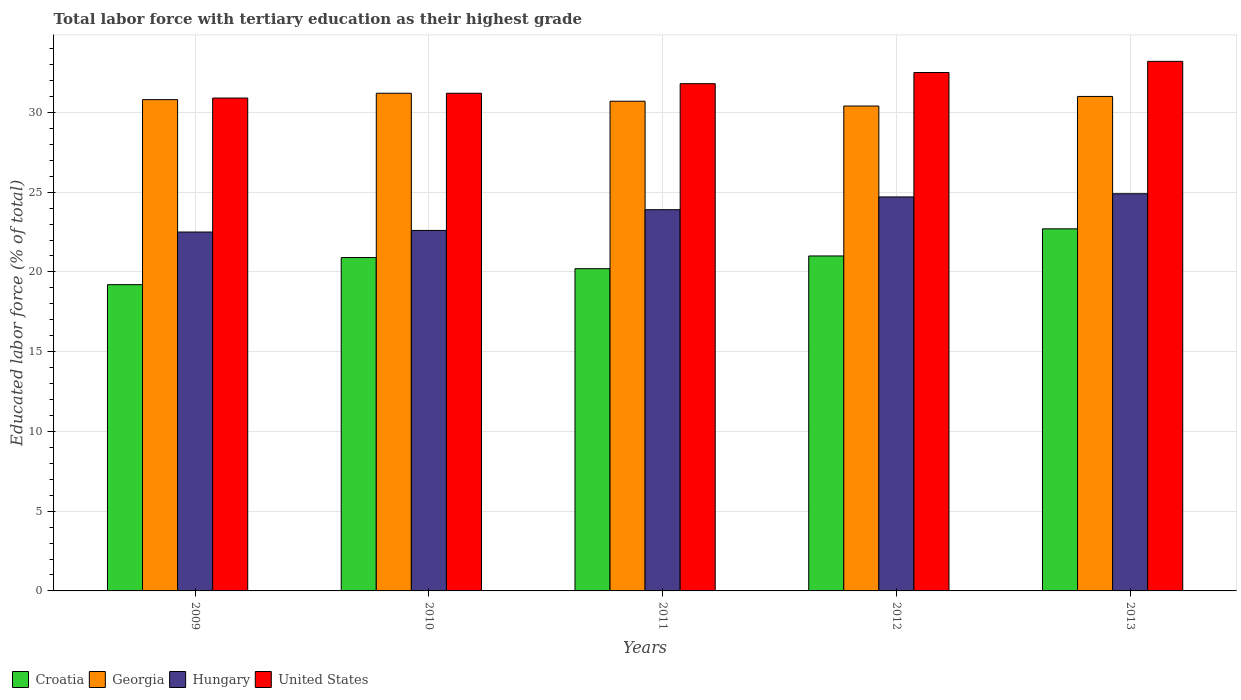How many groups of bars are there?
Give a very brief answer. 5. Are the number of bars on each tick of the X-axis equal?
Make the answer very short. Yes. What is the label of the 4th group of bars from the left?
Ensure brevity in your answer.  2012. In how many cases, is the number of bars for a given year not equal to the number of legend labels?
Your answer should be compact. 0. What is the percentage of male labor force with tertiary education in Georgia in 2010?
Offer a very short reply. 31.2. Across all years, what is the maximum percentage of male labor force with tertiary education in Croatia?
Offer a very short reply. 22.7. Across all years, what is the minimum percentage of male labor force with tertiary education in Georgia?
Provide a succinct answer. 30.4. In which year was the percentage of male labor force with tertiary education in Croatia maximum?
Ensure brevity in your answer.  2013. What is the total percentage of male labor force with tertiary education in Georgia in the graph?
Make the answer very short. 154.1. What is the difference between the percentage of male labor force with tertiary education in Croatia in 2009 and that in 2013?
Offer a terse response. -3.5. What is the difference between the percentage of male labor force with tertiary education in United States in 2009 and the percentage of male labor force with tertiary education in Hungary in 2012?
Keep it short and to the point. 6.2. What is the average percentage of male labor force with tertiary education in Hungary per year?
Offer a very short reply. 23.72. In the year 2009, what is the difference between the percentage of male labor force with tertiary education in Croatia and percentage of male labor force with tertiary education in United States?
Your response must be concise. -11.7. What is the ratio of the percentage of male labor force with tertiary education in Georgia in 2010 to that in 2011?
Your answer should be compact. 1.02. Is the difference between the percentage of male labor force with tertiary education in Croatia in 2009 and 2013 greater than the difference between the percentage of male labor force with tertiary education in United States in 2009 and 2013?
Your response must be concise. No. What is the difference between the highest and the second highest percentage of male labor force with tertiary education in Georgia?
Your answer should be very brief. 0.2. What is the difference between the highest and the lowest percentage of male labor force with tertiary education in Hungary?
Provide a short and direct response. 2.4. In how many years, is the percentage of male labor force with tertiary education in Georgia greater than the average percentage of male labor force with tertiary education in Georgia taken over all years?
Your answer should be very brief. 2. What does the 2nd bar from the left in 2011 represents?
Keep it short and to the point. Georgia. Is it the case that in every year, the sum of the percentage of male labor force with tertiary education in Croatia and percentage of male labor force with tertiary education in Georgia is greater than the percentage of male labor force with tertiary education in Hungary?
Your answer should be very brief. Yes. Are all the bars in the graph horizontal?
Your response must be concise. No. What is the difference between two consecutive major ticks on the Y-axis?
Offer a terse response. 5. Are the values on the major ticks of Y-axis written in scientific E-notation?
Offer a terse response. No. Does the graph contain any zero values?
Offer a very short reply. No. Does the graph contain grids?
Keep it short and to the point. Yes. Where does the legend appear in the graph?
Provide a short and direct response. Bottom left. How are the legend labels stacked?
Give a very brief answer. Horizontal. What is the title of the graph?
Make the answer very short. Total labor force with tertiary education as their highest grade. Does "Malaysia" appear as one of the legend labels in the graph?
Ensure brevity in your answer.  No. What is the label or title of the X-axis?
Your answer should be very brief. Years. What is the label or title of the Y-axis?
Keep it short and to the point. Educated labor force (% of total). What is the Educated labor force (% of total) of Croatia in 2009?
Give a very brief answer. 19.2. What is the Educated labor force (% of total) of Georgia in 2009?
Provide a succinct answer. 30.8. What is the Educated labor force (% of total) in United States in 2009?
Offer a terse response. 30.9. What is the Educated labor force (% of total) of Croatia in 2010?
Give a very brief answer. 20.9. What is the Educated labor force (% of total) of Georgia in 2010?
Make the answer very short. 31.2. What is the Educated labor force (% of total) in Hungary in 2010?
Make the answer very short. 22.6. What is the Educated labor force (% of total) of United States in 2010?
Ensure brevity in your answer.  31.2. What is the Educated labor force (% of total) in Croatia in 2011?
Make the answer very short. 20.2. What is the Educated labor force (% of total) of Georgia in 2011?
Your answer should be very brief. 30.7. What is the Educated labor force (% of total) of Hungary in 2011?
Offer a terse response. 23.9. What is the Educated labor force (% of total) of United States in 2011?
Make the answer very short. 31.8. What is the Educated labor force (% of total) of Georgia in 2012?
Offer a terse response. 30.4. What is the Educated labor force (% of total) of Hungary in 2012?
Offer a very short reply. 24.7. What is the Educated labor force (% of total) in United States in 2012?
Offer a very short reply. 32.5. What is the Educated labor force (% of total) of Croatia in 2013?
Provide a succinct answer. 22.7. What is the Educated labor force (% of total) in Hungary in 2013?
Provide a short and direct response. 24.9. What is the Educated labor force (% of total) in United States in 2013?
Your answer should be very brief. 33.2. Across all years, what is the maximum Educated labor force (% of total) in Croatia?
Keep it short and to the point. 22.7. Across all years, what is the maximum Educated labor force (% of total) of Georgia?
Your response must be concise. 31.2. Across all years, what is the maximum Educated labor force (% of total) in Hungary?
Make the answer very short. 24.9. Across all years, what is the maximum Educated labor force (% of total) of United States?
Provide a short and direct response. 33.2. Across all years, what is the minimum Educated labor force (% of total) of Croatia?
Your answer should be very brief. 19.2. Across all years, what is the minimum Educated labor force (% of total) in Georgia?
Make the answer very short. 30.4. Across all years, what is the minimum Educated labor force (% of total) of United States?
Your response must be concise. 30.9. What is the total Educated labor force (% of total) in Croatia in the graph?
Offer a very short reply. 104. What is the total Educated labor force (% of total) of Georgia in the graph?
Provide a short and direct response. 154.1. What is the total Educated labor force (% of total) of Hungary in the graph?
Provide a succinct answer. 118.6. What is the total Educated labor force (% of total) of United States in the graph?
Offer a terse response. 159.6. What is the difference between the Educated labor force (% of total) of Georgia in 2009 and that in 2010?
Provide a short and direct response. -0.4. What is the difference between the Educated labor force (% of total) in Hungary in 2009 and that in 2010?
Keep it short and to the point. -0.1. What is the difference between the Educated labor force (% of total) in United States in 2009 and that in 2010?
Give a very brief answer. -0.3. What is the difference between the Educated labor force (% of total) in Croatia in 2009 and that in 2011?
Your answer should be compact. -1. What is the difference between the Educated labor force (% of total) in Georgia in 2009 and that in 2011?
Keep it short and to the point. 0.1. What is the difference between the Educated labor force (% of total) in Hungary in 2009 and that in 2011?
Ensure brevity in your answer.  -1.4. What is the difference between the Educated labor force (% of total) in United States in 2009 and that in 2011?
Your response must be concise. -0.9. What is the difference between the Educated labor force (% of total) of Georgia in 2009 and that in 2012?
Your response must be concise. 0.4. What is the difference between the Educated labor force (% of total) of United States in 2009 and that in 2012?
Keep it short and to the point. -1.6. What is the difference between the Educated labor force (% of total) in Georgia in 2009 and that in 2013?
Provide a short and direct response. -0.2. What is the difference between the Educated labor force (% of total) of Hungary in 2009 and that in 2013?
Ensure brevity in your answer.  -2.4. What is the difference between the Educated labor force (% of total) of United States in 2009 and that in 2013?
Your answer should be very brief. -2.3. What is the difference between the Educated labor force (% of total) of United States in 2010 and that in 2011?
Offer a very short reply. -0.6. What is the difference between the Educated labor force (% of total) of Croatia in 2010 and that in 2012?
Your answer should be very brief. -0.1. What is the difference between the Educated labor force (% of total) in Georgia in 2010 and that in 2012?
Provide a short and direct response. 0.8. What is the difference between the Educated labor force (% of total) in Hungary in 2010 and that in 2012?
Make the answer very short. -2.1. What is the difference between the Educated labor force (% of total) of United States in 2010 and that in 2013?
Offer a very short reply. -2. What is the difference between the Educated labor force (% of total) in Croatia in 2011 and that in 2012?
Provide a succinct answer. -0.8. What is the difference between the Educated labor force (% of total) of United States in 2011 and that in 2012?
Your response must be concise. -0.7. What is the difference between the Educated labor force (% of total) of Croatia in 2011 and that in 2013?
Make the answer very short. -2.5. What is the difference between the Educated labor force (% of total) of Georgia in 2011 and that in 2013?
Provide a short and direct response. -0.3. What is the difference between the Educated labor force (% of total) in Georgia in 2012 and that in 2013?
Ensure brevity in your answer.  -0.6. What is the difference between the Educated labor force (% of total) in Croatia in 2009 and the Educated labor force (% of total) in Hungary in 2010?
Your answer should be compact. -3.4. What is the difference between the Educated labor force (% of total) of Georgia in 2009 and the Educated labor force (% of total) of United States in 2010?
Keep it short and to the point. -0.4. What is the difference between the Educated labor force (% of total) in Croatia in 2009 and the Educated labor force (% of total) in Georgia in 2011?
Your answer should be very brief. -11.5. What is the difference between the Educated labor force (% of total) in Georgia in 2009 and the Educated labor force (% of total) in Hungary in 2011?
Your answer should be very brief. 6.9. What is the difference between the Educated labor force (% of total) in Croatia in 2009 and the Educated labor force (% of total) in Hungary in 2012?
Make the answer very short. -5.5. What is the difference between the Educated labor force (% of total) in Georgia in 2009 and the Educated labor force (% of total) in Hungary in 2012?
Keep it short and to the point. 6.1. What is the difference between the Educated labor force (% of total) of Georgia in 2009 and the Educated labor force (% of total) of United States in 2012?
Your response must be concise. -1.7. What is the difference between the Educated labor force (% of total) in Hungary in 2009 and the Educated labor force (% of total) in United States in 2012?
Provide a succinct answer. -10. What is the difference between the Educated labor force (% of total) of Croatia in 2009 and the Educated labor force (% of total) of United States in 2013?
Ensure brevity in your answer.  -14. What is the difference between the Educated labor force (% of total) of Georgia in 2009 and the Educated labor force (% of total) of United States in 2013?
Your response must be concise. -2.4. What is the difference between the Educated labor force (% of total) in Hungary in 2009 and the Educated labor force (% of total) in United States in 2013?
Ensure brevity in your answer.  -10.7. What is the difference between the Educated labor force (% of total) of Croatia in 2010 and the Educated labor force (% of total) of Georgia in 2011?
Your answer should be compact. -9.8. What is the difference between the Educated labor force (% of total) in Georgia in 2010 and the Educated labor force (% of total) in Hungary in 2011?
Offer a terse response. 7.3. What is the difference between the Educated labor force (% of total) in Croatia in 2010 and the Educated labor force (% of total) in Georgia in 2012?
Offer a terse response. -9.5. What is the difference between the Educated labor force (% of total) of Croatia in 2010 and the Educated labor force (% of total) of Hungary in 2012?
Your answer should be very brief. -3.8. What is the difference between the Educated labor force (% of total) in Georgia in 2010 and the Educated labor force (% of total) in Hungary in 2012?
Your answer should be very brief. 6.5. What is the difference between the Educated labor force (% of total) in Georgia in 2010 and the Educated labor force (% of total) in United States in 2012?
Offer a terse response. -1.3. What is the difference between the Educated labor force (% of total) in Hungary in 2010 and the Educated labor force (% of total) in United States in 2012?
Your answer should be compact. -9.9. What is the difference between the Educated labor force (% of total) of Croatia in 2010 and the Educated labor force (% of total) of Georgia in 2013?
Keep it short and to the point. -10.1. What is the difference between the Educated labor force (% of total) in Croatia in 2010 and the Educated labor force (% of total) in Hungary in 2013?
Your answer should be very brief. -4. What is the difference between the Educated labor force (% of total) of Croatia in 2010 and the Educated labor force (% of total) of United States in 2013?
Offer a terse response. -12.3. What is the difference between the Educated labor force (% of total) in Georgia in 2010 and the Educated labor force (% of total) in United States in 2013?
Give a very brief answer. -2. What is the difference between the Educated labor force (% of total) in Hungary in 2010 and the Educated labor force (% of total) in United States in 2013?
Your response must be concise. -10.6. What is the difference between the Educated labor force (% of total) in Croatia in 2011 and the Educated labor force (% of total) in Hungary in 2012?
Make the answer very short. -4.5. What is the difference between the Educated labor force (% of total) of Croatia in 2011 and the Educated labor force (% of total) of United States in 2012?
Your answer should be very brief. -12.3. What is the difference between the Educated labor force (% of total) of Georgia in 2011 and the Educated labor force (% of total) of United States in 2012?
Offer a terse response. -1.8. What is the difference between the Educated labor force (% of total) in Hungary in 2011 and the Educated labor force (% of total) in United States in 2012?
Your response must be concise. -8.6. What is the difference between the Educated labor force (% of total) in Croatia in 2011 and the Educated labor force (% of total) in Hungary in 2013?
Keep it short and to the point. -4.7. What is the difference between the Educated labor force (% of total) in Georgia in 2011 and the Educated labor force (% of total) in Hungary in 2013?
Offer a very short reply. 5.8. What is the difference between the Educated labor force (% of total) in Croatia in 2012 and the Educated labor force (% of total) in Hungary in 2013?
Offer a terse response. -3.9. What is the difference between the Educated labor force (% of total) of Croatia in 2012 and the Educated labor force (% of total) of United States in 2013?
Your answer should be compact. -12.2. What is the difference between the Educated labor force (% of total) of Georgia in 2012 and the Educated labor force (% of total) of Hungary in 2013?
Provide a succinct answer. 5.5. What is the difference between the Educated labor force (% of total) in Georgia in 2012 and the Educated labor force (% of total) in United States in 2013?
Provide a succinct answer. -2.8. What is the difference between the Educated labor force (% of total) in Hungary in 2012 and the Educated labor force (% of total) in United States in 2013?
Offer a very short reply. -8.5. What is the average Educated labor force (% of total) in Croatia per year?
Give a very brief answer. 20.8. What is the average Educated labor force (% of total) in Georgia per year?
Offer a very short reply. 30.82. What is the average Educated labor force (% of total) of Hungary per year?
Provide a succinct answer. 23.72. What is the average Educated labor force (% of total) in United States per year?
Ensure brevity in your answer.  31.92. In the year 2009, what is the difference between the Educated labor force (% of total) of Croatia and Educated labor force (% of total) of Hungary?
Ensure brevity in your answer.  -3.3. In the year 2009, what is the difference between the Educated labor force (% of total) of Croatia and Educated labor force (% of total) of United States?
Ensure brevity in your answer.  -11.7. In the year 2009, what is the difference between the Educated labor force (% of total) in Georgia and Educated labor force (% of total) in Hungary?
Your answer should be compact. 8.3. In the year 2010, what is the difference between the Educated labor force (% of total) in Croatia and Educated labor force (% of total) in Hungary?
Offer a very short reply. -1.7. In the year 2010, what is the difference between the Educated labor force (% of total) in Croatia and Educated labor force (% of total) in United States?
Offer a very short reply. -10.3. In the year 2011, what is the difference between the Educated labor force (% of total) of Hungary and Educated labor force (% of total) of United States?
Your response must be concise. -7.9. In the year 2012, what is the difference between the Educated labor force (% of total) of Croatia and Educated labor force (% of total) of Hungary?
Your answer should be compact. -3.7. In the year 2012, what is the difference between the Educated labor force (% of total) of Hungary and Educated labor force (% of total) of United States?
Ensure brevity in your answer.  -7.8. In the year 2013, what is the difference between the Educated labor force (% of total) in Croatia and Educated labor force (% of total) in Georgia?
Your response must be concise. -8.3. In the year 2013, what is the difference between the Educated labor force (% of total) of Croatia and Educated labor force (% of total) of Hungary?
Your response must be concise. -2.2. In the year 2013, what is the difference between the Educated labor force (% of total) in Hungary and Educated labor force (% of total) in United States?
Provide a short and direct response. -8.3. What is the ratio of the Educated labor force (% of total) of Croatia in 2009 to that in 2010?
Keep it short and to the point. 0.92. What is the ratio of the Educated labor force (% of total) in Georgia in 2009 to that in 2010?
Offer a very short reply. 0.99. What is the ratio of the Educated labor force (% of total) of Hungary in 2009 to that in 2010?
Your answer should be compact. 1. What is the ratio of the Educated labor force (% of total) in Croatia in 2009 to that in 2011?
Provide a short and direct response. 0.95. What is the ratio of the Educated labor force (% of total) of Georgia in 2009 to that in 2011?
Keep it short and to the point. 1. What is the ratio of the Educated labor force (% of total) of Hungary in 2009 to that in 2011?
Offer a terse response. 0.94. What is the ratio of the Educated labor force (% of total) in United States in 2009 to that in 2011?
Provide a short and direct response. 0.97. What is the ratio of the Educated labor force (% of total) in Croatia in 2009 to that in 2012?
Give a very brief answer. 0.91. What is the ratio of the Educated labor force (% of total) in Georgia in 2009 to that in 2012?
Your answer should be very brief. 1.01. What is the ratio of the Educated labor force (% of total) in Hungary in 2009 to that in 2012?
Give a very brief answer. 0.91. What is the ratio of the Educated labor force (% of total) in United States in 2009 to that in 2012?
Provide a short and direct response. 0.95. What is the ratio of the Educated labor force (% of total) of Croatia in 2009 to that in 2013?
Offer a very short reply. 0.85. What is the ratio of the Educated labor force (% of total) in Hungary in 2009 to that in 2013?
Your answer should be very brief. 0.9. What is the ratio of the Educated labor force (% of total) of United States in 2009 to that in 2013?
Provide a succinct answer. 0.93. What is the ratio of the Educated labor force (% of total) in Croatia in 2010 to that in 2011?
Provide a succinct answer. 1.03. What is the ratio of the Educated labor force (% of total) of Georgia in 2010 to that in 2011?
Offer a very short reply. 1.02. What is the ratio of the Educated labor force (% of total) in Hungary in 2010 to that in 2011?
Provide a succinct answer. 0.95. What is the ratio of the Educated labor force (% of total) of United States in 2010 to that in 2011?
Provide a short and direct response. 0.98. What is the ratio of the Educated labor force (% of total) of Croatia in 2010 to that in 2012?
Your response must be concise. 1. What is the ratio of the Educated labor force (% of total) of Georgia in 2010 to that in 2012?
Make the answer very short. 1.03. What is the ratio of the Educated labor force (% of total) of Hungary in 2010 to that in 2012?
Keep it short and to the point. 0.92. What is the ratio of the Educated labor force (% of total) in Croatia in 2010 to that in 2013?
Your response must be concise. 0.92. What is the ratio of the Educated labor force (% of total) of Hungary in 2010 to that in 2013?
Offer a terse response. 0.91. What is the ratio of the Educated labor force (% of total) of United States in 2010 to that in 2013?
Ensure brevity in your answer.  0.94. What is the ratio of the Educated labor force (% of total) in Croatia in 2011 to that in 2012?
Offer a terse response. 0.96. What is the ratio of the Educated labor force (% of total) in Georgia in 2011 to that in 2012?
Ensure brevity in your answer.  1.01. What is the ratio of the Educated labor force (% of total) in Hungary in 2011 to that in 2012?
Ensure brevity in your answer.  0.97. What is the ratio of the Educated labor force (% of total) in United States in 2011 to that in 2012?
Give a very brief answer. 0.98. What is the ratio of the Educated labor force (% of total) of Croatia in 2011 to that in 2013?
Offer a very short reply. 0.89. What is the ratio of the Educated labor force (% of total) of Georgia in 2011 to that in 2013?
Your response must be concise. 0.99. What is the ratio of the Educated labor force (% of total) of Hungary in 2011 to that in 2013?
Provide a short and direct response. 0.96. What is the ratio of the Educated labor force (% of total) of United States in 2011 to that in 2013?
Give a very brief answer. 0.96. What is the ratio of the Educated labor force (% of total) in Croatia in 2012 to that in 2013?
Keep it short and to the point. 0.93. What is the ratio of the Educated labor force (% of total) in Georgia in 2012 to that in 2013?
Your answer should be compact. 0.98. What is the ratio of the Educated labor force (% of total) of Hungary in 2012 to that in 2013?
Offer a terse response. 0.99. What is the ratio of the Educated labor force (% of total) of United States in 2012 to that in 2013?
Give a very brief answer. 0.98. What is the difference between the highest and the second highest Educated labor force (% of total) of Georgia?
Your answer should be very brief. 0.2. What is the difference between the highest and the second highest Educated labor force (% of total) of United States?
Make the answer very short. 0.7. What is the difference between the highest and the lowest Educated labor force (% of total) in Croatia?
Make the answer very short. 3.5. What is the difference between the highest and the lowest Educated labor force (% of total) in United States?
Your answer should be compact. 2.3. 